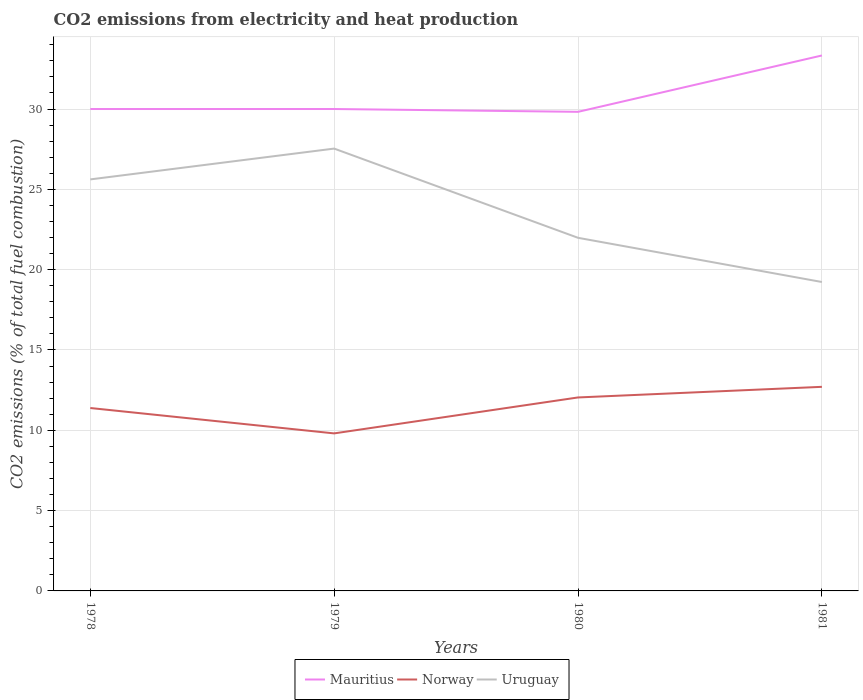How many different coloured lines are there?
Keep it short and to the point. 3. Does the line corresponding to Uruguay intersect with the line corresponding to Norway?
Keep it short and to the point. No. Is the number of lines equal to the number of legend labels?
Your response must be concise. Yes. Across all years, what is the maximum amount of CO2 emitted in Uruguay?
Provide a succinct answer. 19.23. In which year was the amount of CO2 emitted in Norway maximum?
Offer a very short reply. 1979. What is the total amount of CO2 emitted in Mauritius in the graph?
Keep it short and to the point. -3.33. What is the difference between the highest and the second highest amount of CO2 emitted in Mauritius?
Your response must be concise. 3.51. Is the amount of CO2 emitted in Norway strictly greater than the amount of CO2 emitted in Mauritius over the years?
Offer a terse response. Yes. How many lines are there?
Your answer should be compact. 3. How many years are there in the graph?
Your response must be concise. 4. Does the graph contain any zero values?
Your answer should be very brief. No. How many legend labels are there?
Your answer should be compact. 3. What is the title of the graph?
Offer a terse response. CO2 emissions from electricity and heat production. What is the label or title of the Y-axis?
Provide a succinct answer. CO2 emissions (% of total fuel combustion). What is the CO2 emissions (% of total fuel combustion) in Norway in 1978?
Your answer should be compact. 11.39. What is the CO2 emissions (% of total fuel combustion) of Uruguay in 1978?
Your answer should be compact. 25.62. What is the CO2 emissions (% of total fuel combustion) of Mauritius in 1979?
Offer a terse response. 30. What is the CO2 emissions (% of total fuel combustion) of Norway in 1979?
Your answer should be compact. 9.81. What is the CO2 emissions (% of total fuel combustion) of Uruguay in 1979?
Keep it short and to the point. 27.54. What is the CO2 emissions (% of total fuel combustion) of Mauritius in 1980?
Ensure brevity in your answer.  29.82. What is the CO2 emissions (% of total fuel combustion) of Norway in 1980?
Keep it short and to the point. 12.04. What is the CO2 emissions (% of total fuel combustion) in Uruguay in 1980?
Offer a terse response. 21.98. What is the CO2 emissions (% of total fuel combustion) in Mauritius in 1981?
Keep it short and to the point. 33.33. What is the CO2 emissions (% of total fuel combustion) in Norway in 1981?
Offer a terse response. 12.71. What is the CO2 emissions (% of total fuel combustion) of Uruguay in 1981?
Your response must be concise. 19.23. Across all years, what is the maximum CO2 emissions (% of total fuel combustion) in Mauritius?
Your answer should be compact. 33.33. Across all years, what is the maximum CO2 emissions (% of total fuel combustion) of Norway?
Keep it short and to the point. 12.71. Across all years, what is the maximum CO2 emissions (% of total fuel combustion) of Uruguay?
Provide a succinct answer. 27.54. Across all years, what is the minimum CO2 emissions (% of total fuel combustion) in Mauritius?
Your response must be concise. 29.82. Across all years, what is the minimum CO2 emissions (% of total fuel combustion) in Norway?
Give a very brief answer. 9.81. Across all years, what is the minimum CO2 emissions (% of total fuel combustion) in Uruguay?
Give a very brief answer. 19.23. What is the total CO2 emissions (% of total fuel combustion) of Mauritius in the graph?
Make the answer very short. 123.16. What is the total CO2 emissions (% of total fuel combustion) of Norway in the graph?
Keep it short and to the point. 45.94. What is the total CO2 emissions (% of total fuel combustion) of Uruguay in the graph?
Your answer should be compact. 94.37. What is the difference between the CO2 emissions (% of total fuel combustion) in Norway in 1978 and that in 1979?
Offer a terse response. 1.58. What is the difference between the CO2 emissions (% of total fuel combustion) in Uruguay in 1978 and that in 1979?
Give a very brief answer. -1.92. What is the difference between the CO2 emissions (% of total fuel combustion) in Mauritius in 1978 and that in 1980?
Make the answer very short. 0.18. What is the difference between the CO2 emissions (% of total fuel combustion) of Norway in 1978 and that in 1980?
Keep it short and to the point. -0.66. What is the difference between the CO2 emissions (% of total fuel combustion) in Uruguay in 1978 and that in 1980?
Ensure brevity in your answer.  3.64. What is the difference between the CO2 emissions (% of total fuel combustion) in Norway in 1978 and that in 1981?
Offer a terse response. -1.32. What is the difference between the CO2 emissions (% of total fuel combustion) of Uruguay in 1978 and that in 1981?
Give a very brief answer. 6.39. What is the difference between the CO2 emissions (% of total fuel combustion) in Mauritius in 1979 and that in 1980?
Make the answer very short. 0.18. What is the difference between the CO2 emissions (% of total fuel combustion) in Norway in 1979 and that in 1980?
Provide a succinct answer. -2.24. What is the difference between the CO2 emissions (% of total fuel combustion) in Uruguay in 1979 and that in 1980?
Ensure brevity in your answer.  5.55. What is the difference between the CO2 emissions (% of total fuel combustion) of Mauritius in 1979 and that in 1981?
Your response must be concise. -3.33. What is the difference between the CO2 emissions (% of total fuel combustion) of Norway in 1979 and that in 1981?
Your answer should be compact. -2.9. What is the difference between the CO2 emissions (% of total fuel combustion) of Uruguay in 1979 and that in 1981?
Give a very brief answer. 8.31. What is the difference between the CO2 emissions (% of total fuel combustion) in Mauritius in 1980 and that in 1981?
Your answer should be very brief. -3.51. What is the difference between the CO2 emissions (% of total fuel combustion) of Norway in 1980 and that in 1981?
Ensure brevity in your answer.  -0.66. What is the difference between the CO2 emissions (% of total fuel combustion) of Uruguay in 1980 and that in 1981?
Give a very brief answer. 2.75. What is the difference between the CO2 emissions (% of total fuel combustion) of Mauritius in 1978 and the CO2 emissions (% of total fuel combustion) of Norway in 1979?
Keep it short and to the point. 20.19. What is the difference between the CO2 emissions (% of total fuel combustion) of Mauritius in 1978 and the CO2 emissions (% of total fuel combustion) of Uruguay in 1979?
Make the answer very short. 2.46. What is the difference between the CO2 emissions (% of total fuel combustion) of Norway in 1978 and the CO2 emissions (% of total fuel combustion) of Uruguay in 1979?
Your response must be concise. -16.15. What is the difference between the CO2 emissions (% of total fuel combustion) of Mauritius in 1978 and the CO2 emissions (% of total fuel combustion) of Norway in 1980?
Keep it short and to the point. 17.96. What is the difference between the CO2 emissions (% of total fuel combustion) in Mauritius in 1978 and the CO2 emissions (% of total fuel combustion) in Uruguay in 1980?
Your response must be concise. 8.02. What is the difference between the CO2 emissions (% of total fuel combustion) of Norway in 1978 and the CO2 emissions (% of total fuel combustion) of Uruguay in 1980?
Offer a very short reply. -10.6. What is the difference between the CO2 emissions (% of total fuel combustion) of Mauritius in 1978 and the CO2 emissions (% of total fuel combustion) of Norway in 1981?
Your response must be concise. 17.29. What is the difference between the CO2 emissions (% of total fuel combustion) in Mauritius in 1978 and the CO2 emissions (% of total fuel combustion) in Uruguay in 1981?
Give a very brief answer. 10.77. What is the difference between the CO2 emissions (% of total fuel combustion) in Norway in 1978 and the CO2 emissions (% of total fuel combustion) in Uruguay in 1981?
Your response must be concise. -7.84. What is the difference between the CO2 emissions (% of total fuel combustion) of Mauritius in 1979 and the CO2 emissions (% of total fuel combustion) of Norway in 1980?
Your answer should be compact. 17.96. What is the difference between the CO2 emissions (% of total fuel combustion) in Mauritius in 1979 and the CO2 emissions (% of total fuel combustion) in Uruguay in 1980?
Provide a succinct answer. 8.02. What is the difference between the CO2 emissions (% of total fuel combustion) of Norway in 1979 and the CO2 emissions (% of total fuel combustion) of Uruguay in 1980?
Provide a succinct answer. -12.18. What is the difference between the CO2 emissions (% of total fuel combustion) of Mauritius in 1979 and the CO2 emissions (% of total fuel combustion) of Norway in 1981?
Make the answer very short. 17.29. What is the difference between the CO2 emissions (% of total fuel combustion) of Mauritius in 1979 and the CO2 emissions (% of total fuel combustion) of Uruguay in 1981?
Your response must be concise. 10.77. What is the difference between the CO2 emissions (% of total fuel combustion) of Norway in 1979 and the CO2 emissions (% of total fuel combustion) of Uruguay in 1981?
Make the answer very short. -9.42. What is the difference between the CO2 emissions (% of total fuel combustion) of Mauritius in 1980 and the CO2 emissions (% of total fuel combustion) of Norway in 1981?
Ensure brevity in your answer.  17.12. What is the difference between the CO2 emissions (% of total fuel combustion) in Mauritius in 1980 and the CO2 emissions (% of total fuel combustion) in Uruguay in 1981?
Your answer should be very brief. 10.59. What is the difference between the CO2 emissions (% of total fuel combustion) in Norway in 1980 and the CO2 emissions (% of total fuel combustion) in Uruguay in 1981?
Give a very brief answer. -7.19. What is the average CO2 emissions (% of total fuel combustion) of Mauritius per year?
Make the answer very short. 30.79. What is the average CO2 emissions (% of total fuel combustion) of Norway per year?
Ensure brevity in your answer.  11.49. What is the average CO2 emissions (% of total fuel combustion) in Uruguay per year?
Ensure brevity in your answer.  23.59. In the year 1978, what is the difference between the CO2 emissions (% of total fuel combustion) in Mauritius and CO2 emissions (% of total fuel combustion) in Norway?
Give a very brief answer. 18.61. In the year 1978, what is the difference between the CO2 emissions (% of total fuel combustion) of Mauritius and CO2 emissions (% of total fuel combustion) of Uruguay?
Your answer should be compact. 4.38. In the year 1978, what is the difference between the CO2 emissions (% of total fuel combustion) of Norway and CO2 emissions (% of total fuel combustion) of Uruguay?
Provide a short and direct response. -14.23. In the year 1979, what is the difference between the CO2 emissions (% of total fuel combustion) of Mauritius and CO2 emissions (% of total fuel combustion) of Norway?
Give a very brief answer. 20.19. In the year 1979, what is the difference between the CO2 emissions (% of total fuel combustion) in Mauritius and CO2 emissions (% of total fuel combustion) in Uruguay?
Provide a succinct answer. 2.46. In the year 1979, what is the difference between the CO2 emissions (% of total fuel combustion) of Norway and CO2 emissions (% of total fuel combustion) of Uruguay?
Offer a very short reply. -17.73. In the year 1980, what is the difference between the CO2 emissions (% of total fuel combustion) of Mauritius and CO2 emissions (% of total fuel combustion) of Norway?
Keep it short and to the point. 17.78. In the year 1980, what is the difference between the CO2 emissions (% of total fuel combustion) in Mauritius and CO2 emissions (% of total fuel combustion) in Uruguay?
Provide a short and direct response. 7.84. In the year 1980, what is the difference between the CO2 emissions (% of total fuel combustion) in Norway and CO2 emissions (% of total fuel combustion) in Uruguay?
Offer a very short reply. -9.94. In the year 1981, what is the difference between the CO2 emissions (% of total fuel combustion) of Mauritius and CO2 emissions (% of total fuel combustion) of Norway?
Your response must be concise. 20.63. In the year 1981, what is the difference between the CO2 emissions (% of total fuel combustion) in Mauritius and CO2 emissions (% of total fuel combustion) in Uruguay?
Your answer should be very brief. 14.1. In the year 1981, what is the difference between the CO2 emissions (% of total fuel combustion) of Norway and CO2 emissions (% of total fuel combustion) of Uruguay?
Give a very brief answer. -6.53. What is the ratio of the CO2 emissions (% of total fuel combustion) in Norway in 1978 to that in 1979?
Provide a succinct answer. 1.16. What is the ratio of the CO2 emissions (% of total fuel combustion) of Uruguay in 1978 to that in 1979?
Offer a very short reply. 0.93. What is the ratio of the CO2 emissions (% of total fuel combustion) of Mauritius in 1978 to that in 1980?
Provide a succinct answer. 1.01. What is the ratio of the CO2 emissions (% of total fuel combustion) in Norway in 1978 to that in 1980?
Make the answer very short. 0.95. What is the ratio of the CO2 emissions (% of total fuel combustion) of Uruguay in 1978 to that in 1980?
Make the answer very short. 1.17. What is the ratio of the CO2 emissions (% of total fuel combustion) in Norway in 1978 to that in 1981?
Give a very brief answer. 0.9. What is the ratio of the CO2 emissions (% of total fuel combustion) in Uruguay in 1978 to that in 1981?
Your answer should be compact. 1.33. What is the ratio of the CO2 emissions (% of total fuel combustion) in Mauritius in 1979 to that in 1980?
Your response must be concise. 1.01. What is the ratio of the CO2 emissions (% of total fuel combustion) of Norway in 1979 to that in 1980?
Offer a very short reply. 0.81. What is the ratio of the CO2 emissions (% of total fuel combustion) of Uruguay in 1979 to that in 1980?
Provide a short and direct response. 1.25. What is the ratio of the CO2 emissions (% of total fuel combustion) in Norway in 1979 to that in 1981?
Provide a succinct answer. 0.77. What is the ratio of the CO2 emissions (% of total fuel combustion) in Uruguay in 1979 to that in 1981?
Make the answer very short. 1.43. What is the ratio of the CO2 emissions (% of total fuel combustion) in Mauritius in 1980 to that in 1981?
Your answer should be compact. 0.89. What is the ratio of the CO2 emissions (% of total fuel combustion) of Norway in 1980 to that in 1981?
Offer a terse response. 0.95. What is the ratio of the CO2 emissions (% of total fuel combustion) of Uruguay in 1980 to that in 1981?
Your answer should be compact. 1.14. What is the difference between the highest and the second highest CO2 emissions (% of total fuel combustion) of Mauritius?
Ensure brevity in your answer.  3.33. What is the difference between the highest and the second highest CO2 emissions (% of total fuel combustion) in Norway?
Keep it short and to the point. 0.66. What is the difference between the highest and the second highest CO2 emissions (% of total fuel combustion) of Uruguay?
Offer a terse response. 1.92. What is the difference between the highest and the lowest CO2 emissions (% of total fuel combustion) in Mauritius?
Ensure brevity in your answer.  3.51. What is the difference between the highest and the lowest CO2 emissions (% of total fuel combustion) of Norway?
Offer a very short reply. 2.9. What is the difference between the highest and the lowest CO2 emissions (% of total fuel combustion) in Uruguay?
Ensure brevity in your answer.  8.31. 